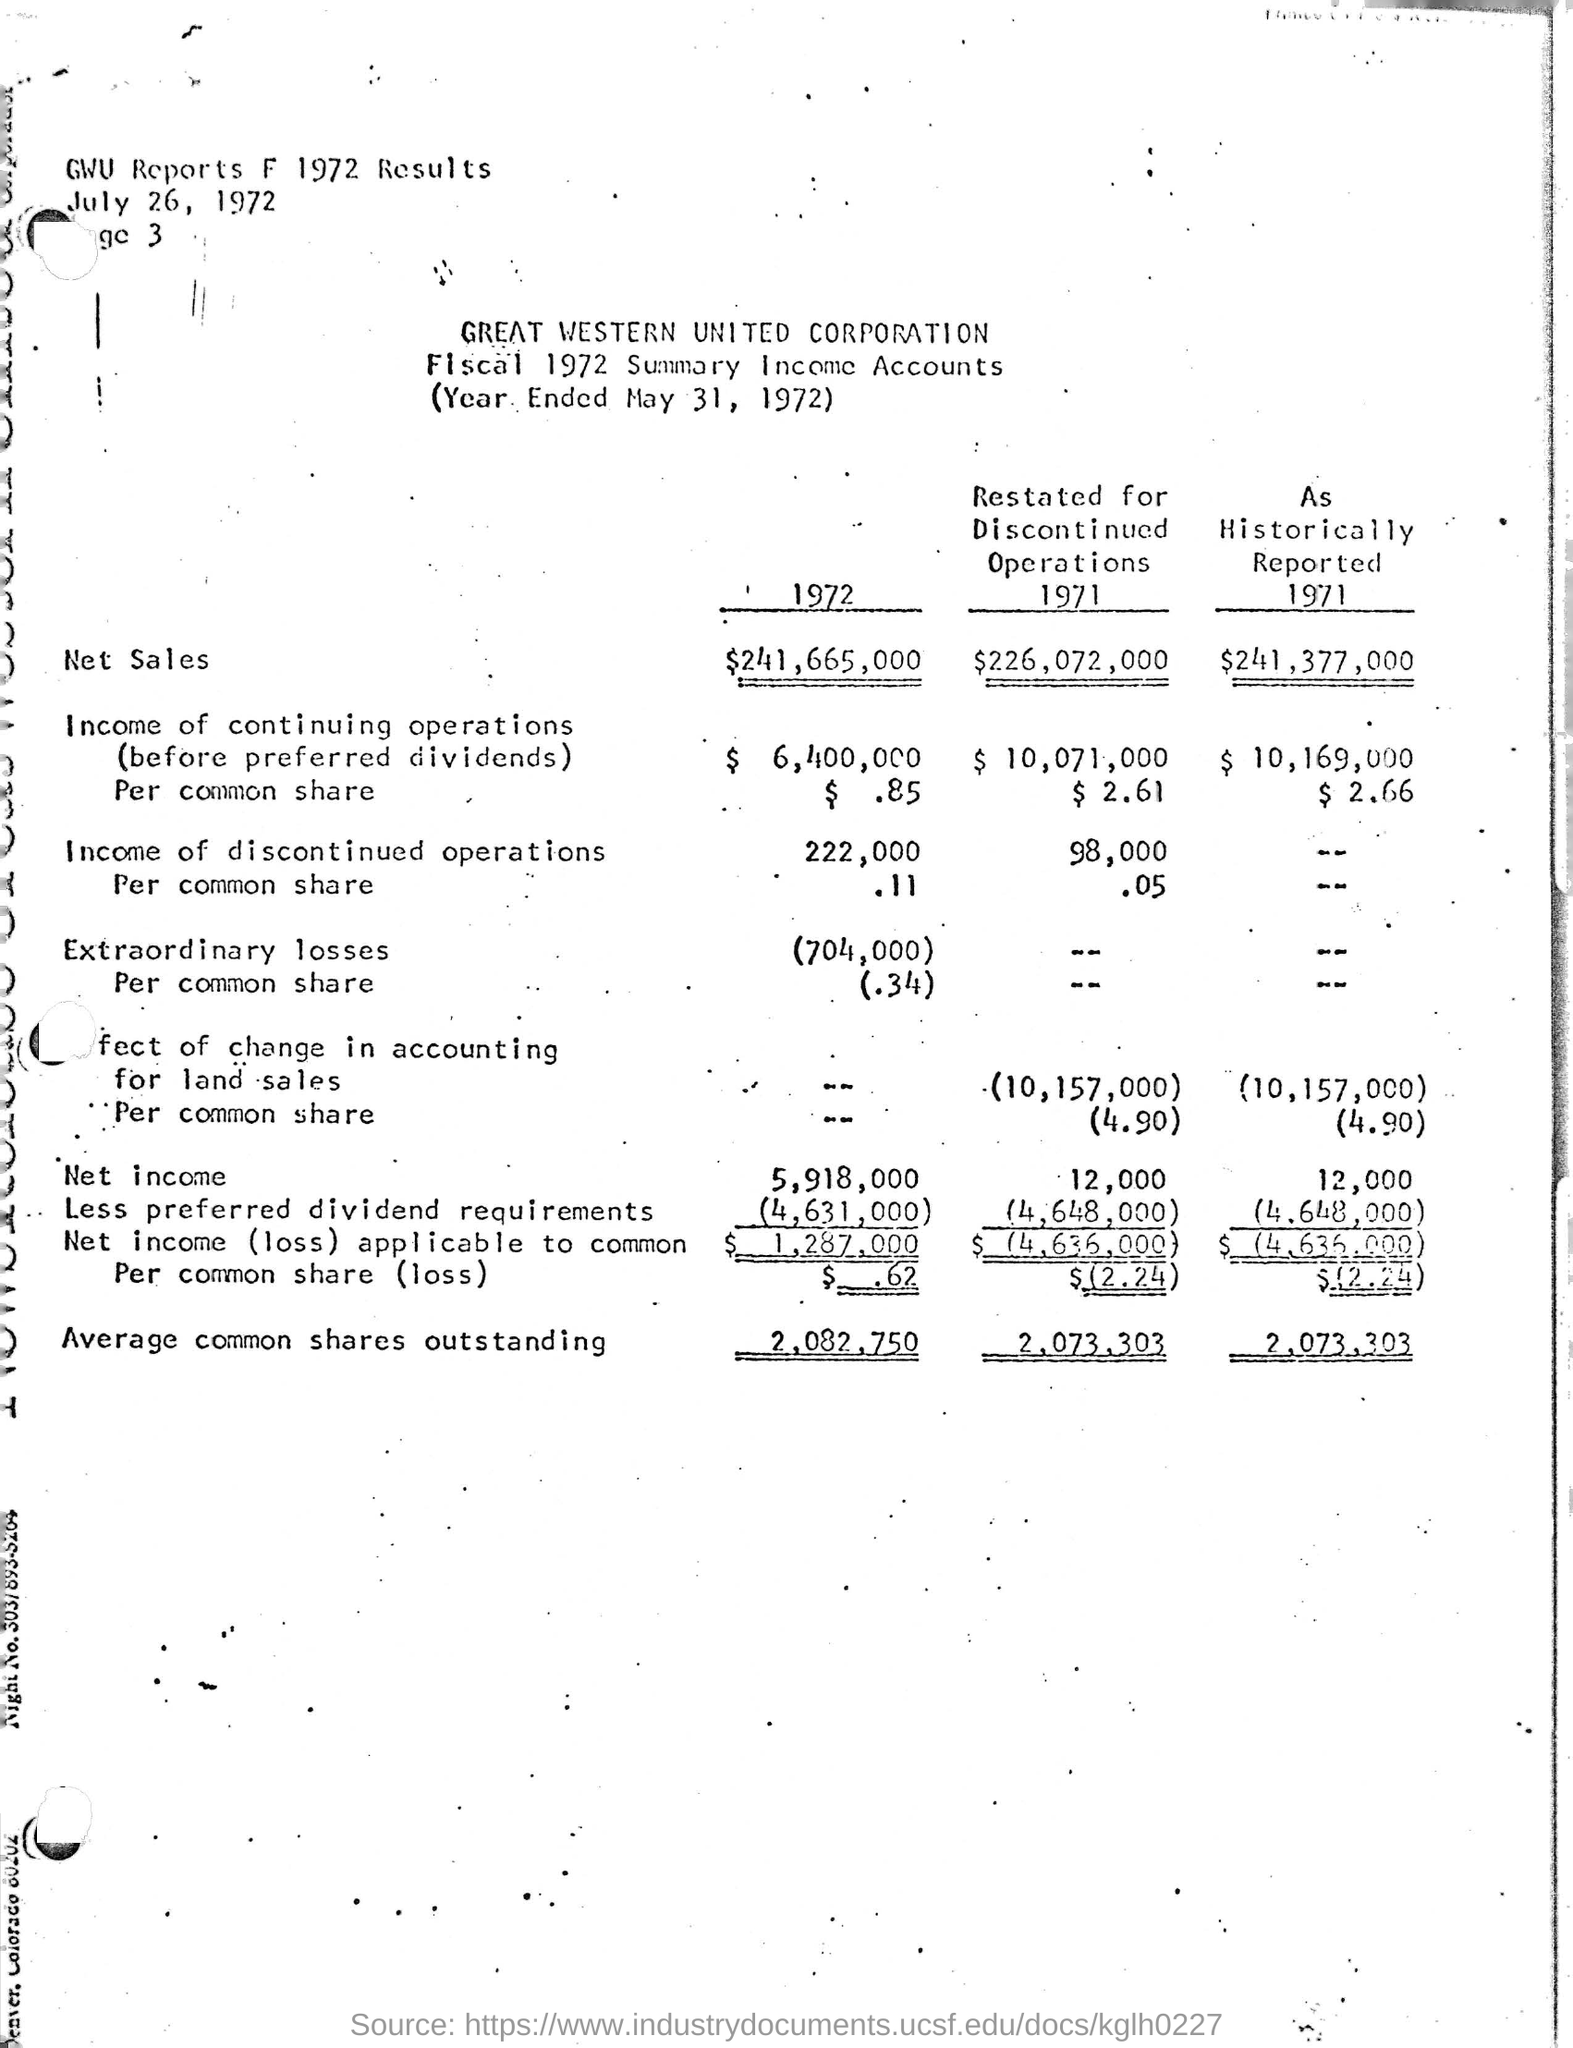Specify some key components in this picture. The net income for the year 1972 was 5,918,000. Great Western United Corporation is the name of the corporation mentioned. The average number of common shares outstanding for the year 1972 was 2,082,750. The date mentioned at the top of the page is July 26, 1972. The net sales amount for the year 1972 was $241,665,000. 